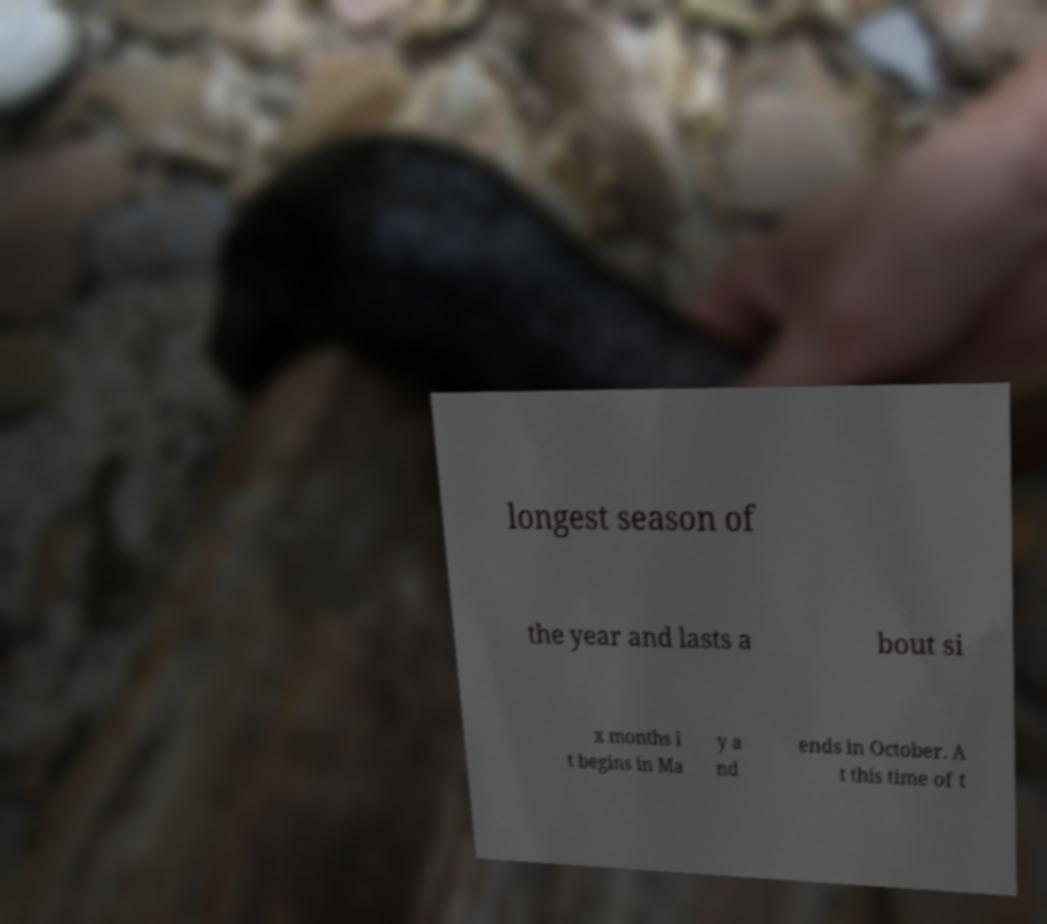What messages or text are displayed in this image? I need them in a readable, typed format. longest season of the year and lasts a bout si x months i t begins in Ma y a nd ends in October. A t this time of t 